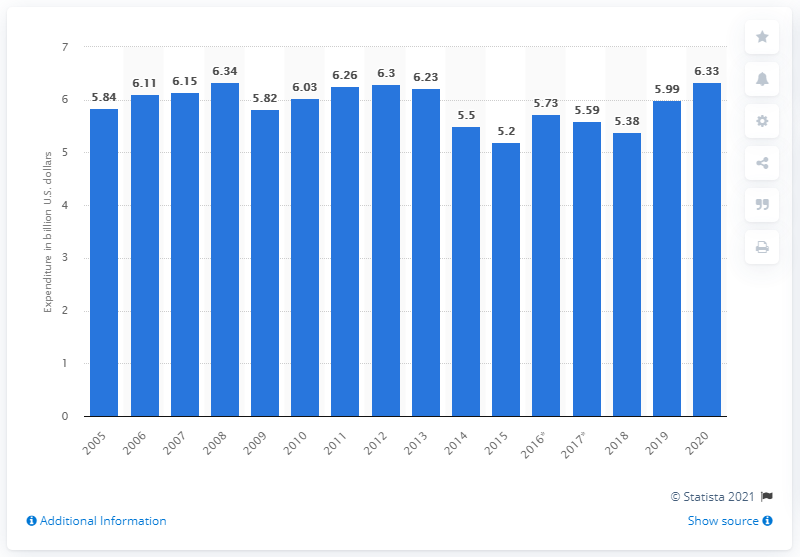Mention a couple of crucial points in this snapshot. IBM spent approximately $6.33 billion in 2020 on research, development, and engineering. IBM receives approximately 6.33 patents per year. 